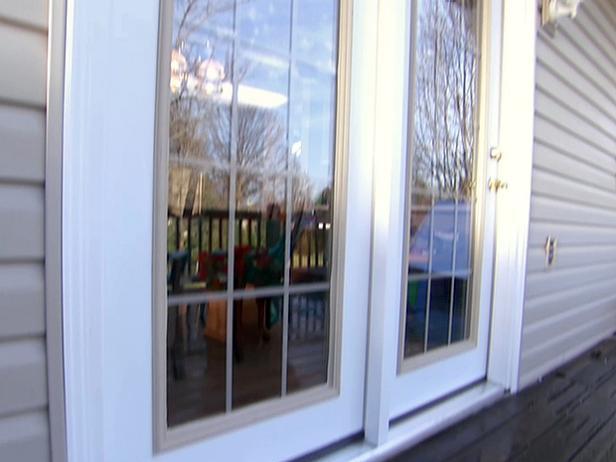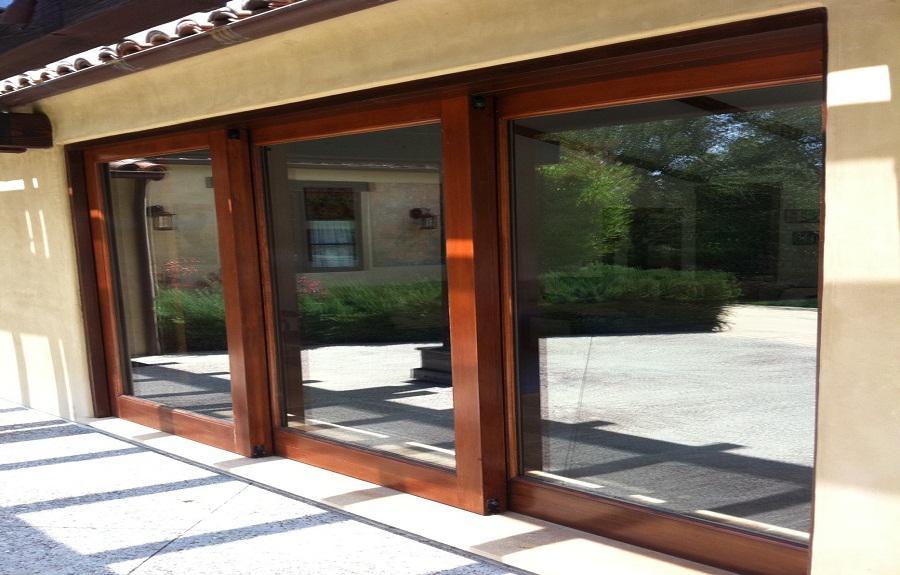The first image is the image on the left, the second image is the image on the right. For the images displayed, is the sentence "All the doors are closed." factually correct? Answer yes or no. Yes. The first image is the image on the left, the second image is the image on the right. For the images displayed, is the sentence "The image on the left has a white wood-trimmed glass door." factually correct? Answer yes or no. Yes. 